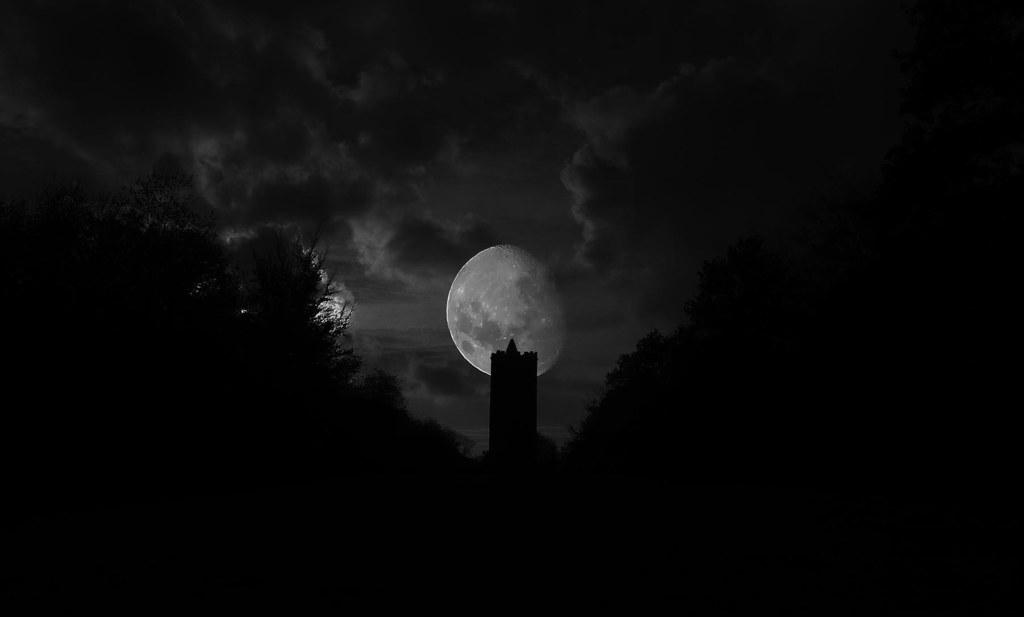What celestial object is visible in the image? There is a half moon in the image. What type of natural vegetation is present in the image? There are trees in the image. What is the condition of the sky in the image? The sky is cloudy in the image. How would you describe the overall lighting or brightness in the image? The image appears to depict a dark place. How many spiders can be seen crawling on the half moon in the image? There are no spiders visible on the half moon in the image. What type of haircut is the half moon sporting in the image? The half moon is a celestial object and does not have a haircut. What type of appliance is being used to create the cloudy sky in the image? The cloudy sky is a natural phenomenon and does not involve the use of any appliances. 